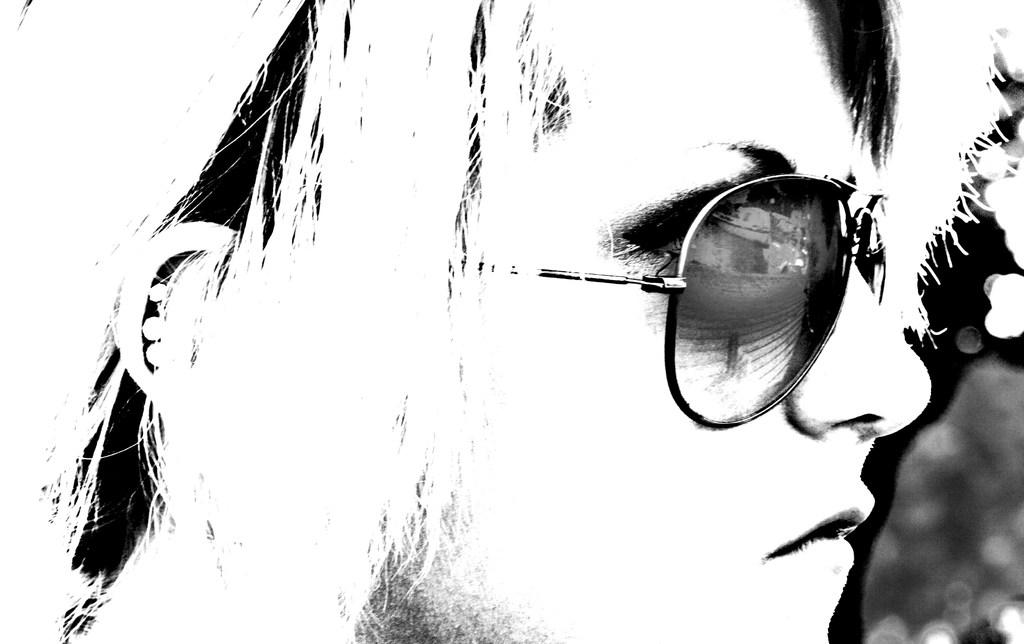Who is the main subject in the image? There is a girl in the image. What subject is the girl teaching in the image? There is no indication in the image that the girl is teaching any subject. How many fingers does the girl have in the image? The number of fingers the girl has cannot be determined from the image alone, as it only shows her as the main subject. 